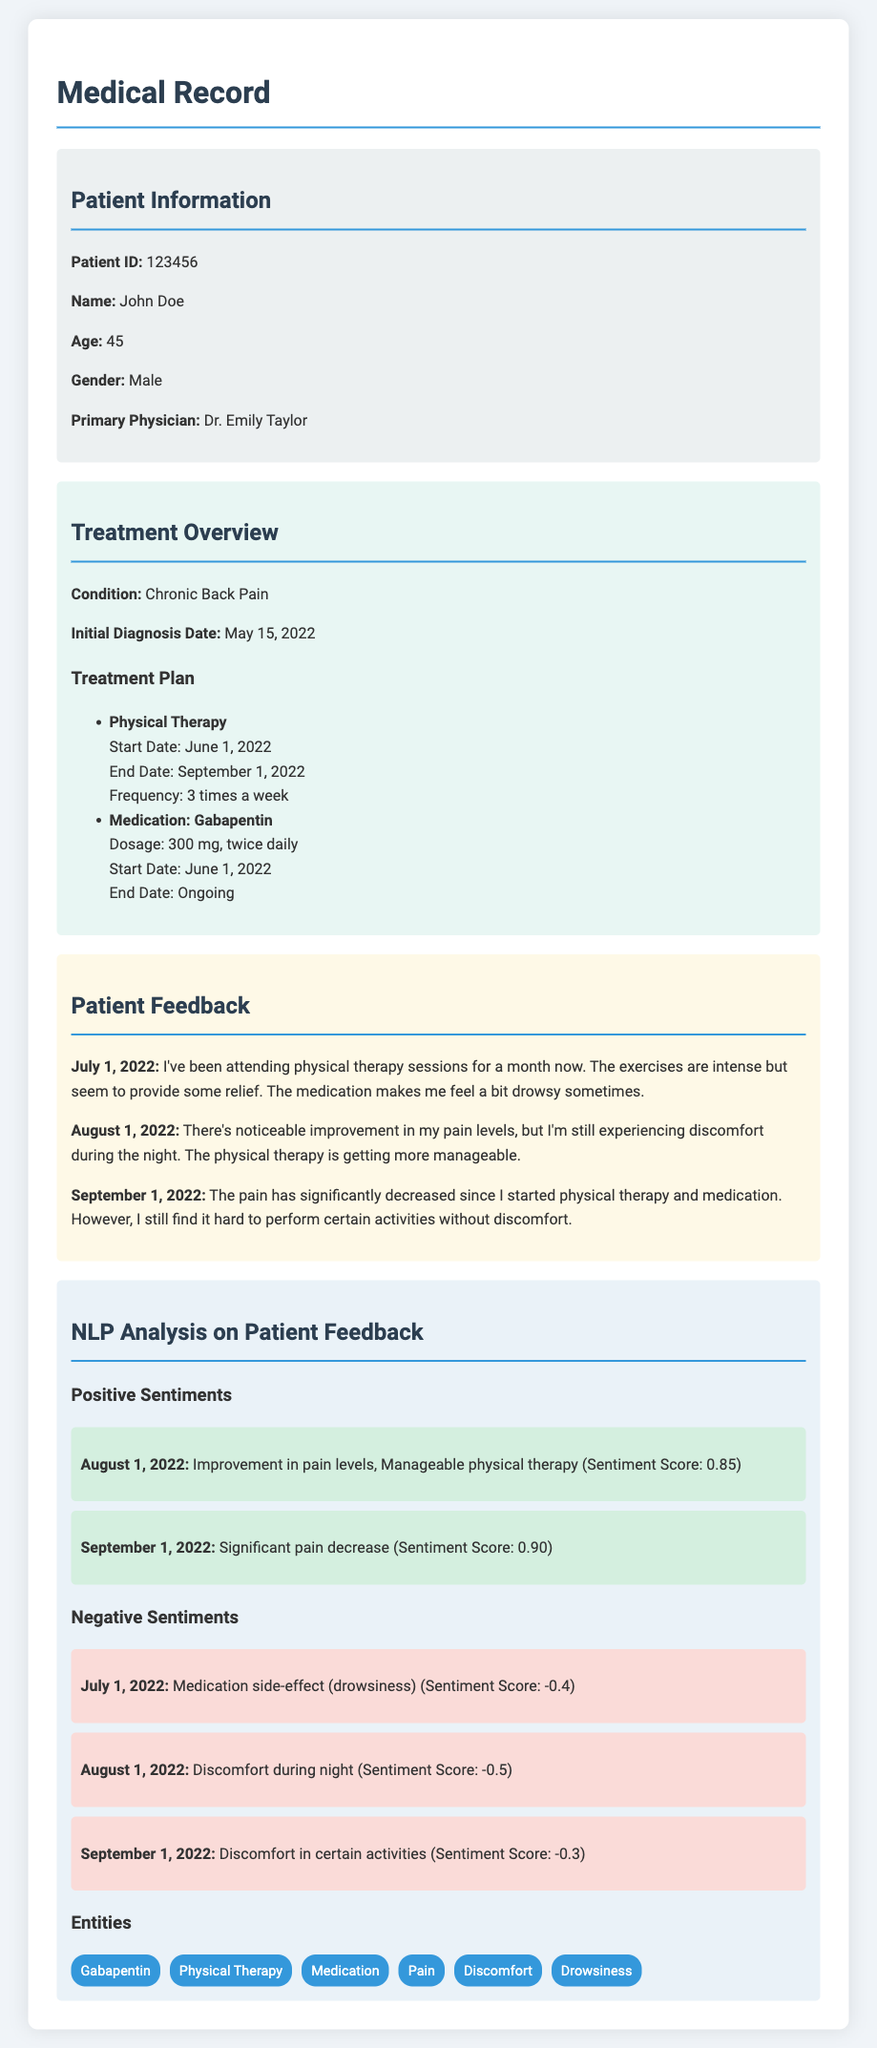What is the patient's age? The patient's age is stated directly in the document under Patient Information.
Answer: 45 Who is the primary physician? The primary physician is mentioned in the Patient Information section of the document.
Answer: Dr. Emily Taylor What is the medication prescribed? The medication is listed in the Treatment Overview section under the Treatment Plan.
Answer: Gabapentin When did John Doe start physical therapy? The start date for physical therapy is provided in the Treatment Plan section.
Answer: June 1, 2022 What is the sentiment score for the feedback on August 1, 2022? The sentiment score is given in the NLP Analysis section under Positive Sentiments for that date.
Answer: 0.85 What condition is being treated? The condition is stated in the Treatment Overview section.
Answer: Chronic Back Pain What month did the patient report improvement in pain levels? Improvement in pain levels is mentioned in the feedback given for August 1, 2022.
Answer: August Which feedback mentions drowsiness as a side effect? The feedback with the mention of drowsiness is listed under July 1, 2022.
Answer: July 1, 2022 How often does the patient attend physical therapy? The frequency of physical therapy sessions is noted in the Treatment Plan section.
Answer: 3 times a week 